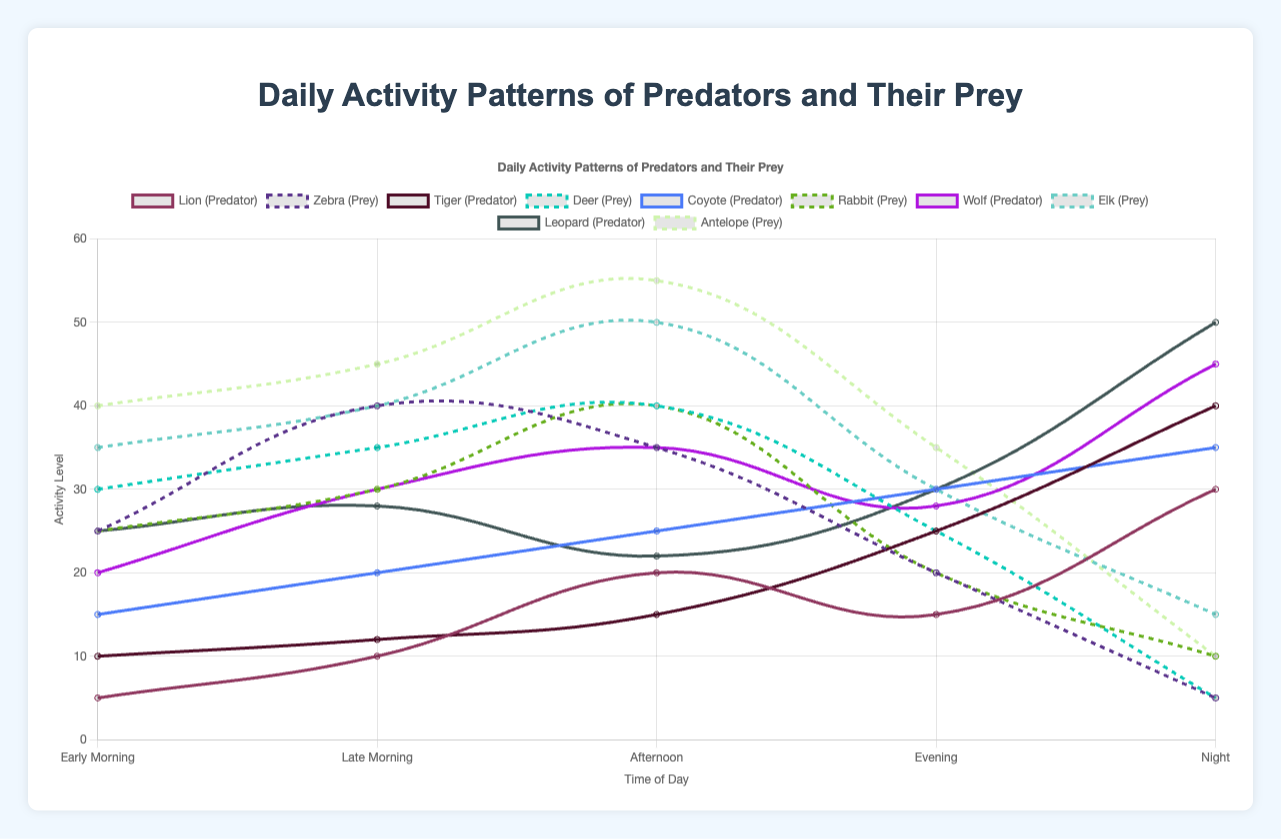What is the peak hunting time for the Lion on January 1st? To find the peak hunting time, observe the highest data point in the predator activity line for the Lion on January 1st. The highest value is 30 at night.
Answer: Night Which predator shows the maximum activity during the late morning period? Look at the late morning values for all predators and compare. The values are: Lion (10), Tiger (12), Coyote (20), Wolf (30), Leopard (28). The maximum activity is shown by the Wolf.
Answer: Wolf During which time of day do the prey animals show the least activity, and which prey has the lowest value? Identify the lowest activity values for the prey during each time of day. The minimal value is in the night for multiple preys: Zebra (5), Deer (5), Rabbit (10), Elk (15), Antelope (10). The lowest values are 5, and both Zebra and Deer exhibit this at night.
Answer: Night, Zebra and Deer Is there any time period where the activity levels of the prey are equal across different species? Compare the activity levels of prey for all time periods. The values show equal activity for Zebra and Deer during the late morning (both 40).
Answer: Late Morning, Zebra and Deer Calculate the average night time activity for all predators. For each predator, note the night activity values: Lion (30), Tiger (40), Coyote (35), Wolf (45), Leopard (50). Sum these values: 30 + 40 + 35 + 45 + 50 = 200, then divide by the number of predators: 200/5 = 40.
Answer: 40 